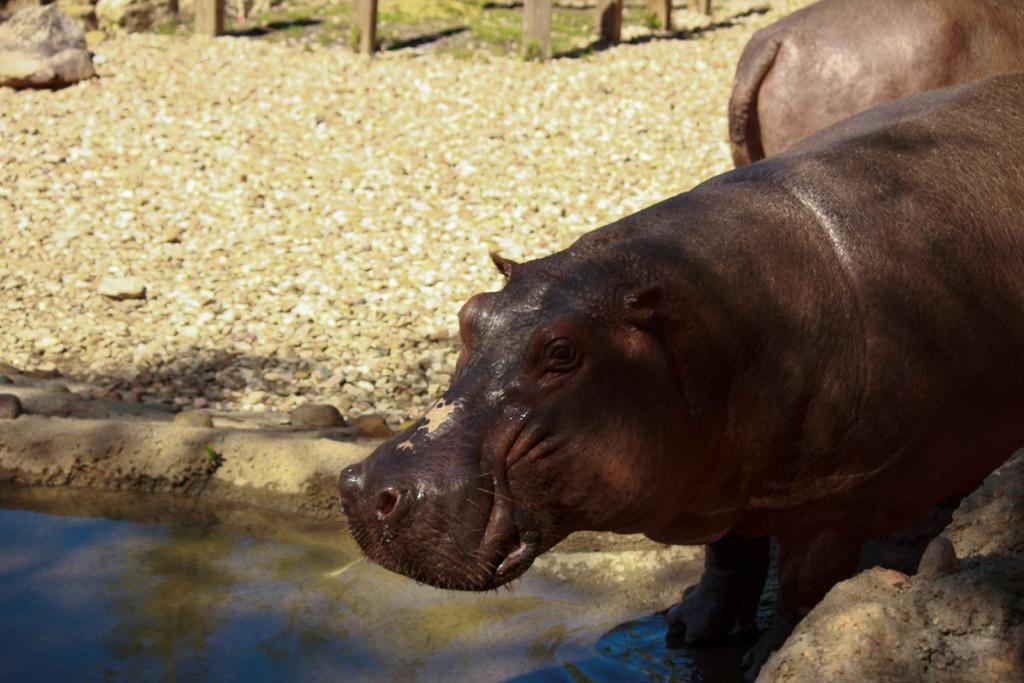What can be seen in the image in terms of living creatures? There are two animals in the image. What is the water surface reflecting in the image? There are reflections of objects on the water in the image. What type of natural environment is visible in the background? There is grass in the background of the image. What type of materials can be seen in the background? There are stones and wooden objects in the background of the image. What reason does the coach give for the achiever's success in the image? There is no coach or achiever present in the image, and therefore no such conversation can be observed. 